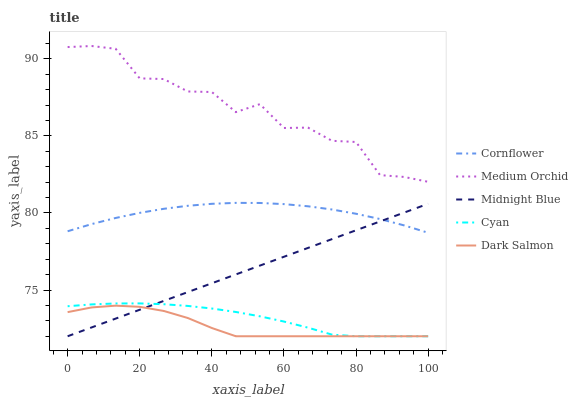Does Dark Salmon have the minimum area under the curve?
Answer yes or no. Yes. Does Medium Orchid have the maximum area under the curve?
Answer yes or no. Yes. Does Medium Orchid have the minimum area under the curve?
Answer yes or no. No. Does Dark Salmon have the maximum area under the curve?
Answer yes or no. No. Is Midnight Blue the smoothest?
Answer yes or no. Yes. Is Medium Orchid the roughest?
Answer yes or no. Yes. Is Dark Salmon the smoothest?
Answer yes or no. No. Is Dark Salmon the roughest?
Answer yes or no. No. Does Dark Salmon have the lowest value?
Answer yes or no. Yes. Does Medium Orchid have the lowest value?
Answer yes or no. No. Does Medium Orchid have the highest value?
Answer yes or no. Yes. Does Dark Salmon have the highest value?
Answer yes or no. No. Is Dark Salmon less than Cornflower?
Answer yes or no. Yes. Is Medium Orchid greater than Cyan?
Answer yes or no. Yes. Does Cornflower intersect Midnight Blue?
Answer yes or no. Yes. Is Cornflower less than Midnight Blue?
Answer yes or no. No. Is Cornflower greater than Midnight Blue?
Answer yes or no. No. Does Dark Salmon intersect Cornflower?
Answer yes or no. No. 